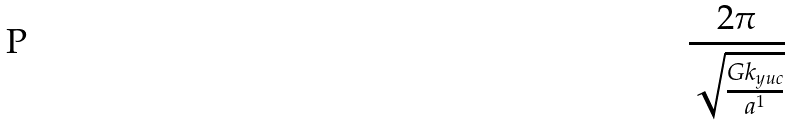<formula> <loc_0><loc_0><loc_500><loc_500>\frac { 2 \pi } { \sqrt { \frac { G k _ { y u c } } { a ^ { 1 } } } }</formula> 